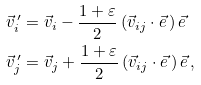<formula> <loc_0><loc_0><loc_500><loc_500>\vec { v } ^ { \, \prime } _ { i } & = \vec { v } _ { i } - \frac { 1 + \varepsilon } { 2 } \left ( \vec { v } _ { i j } \cdot \vec { e } \, \right ) \vec { e } \quad \\ \vec { v } ^ { \, \prime } _ { j } & = \vec { v } _ { j } + \frac { 1 + \varepsilon } { 2 } \left ( \vec { v } _ { i j } \cdot \vec { e } \, \right ) \vec { e } \, ,</formula> 